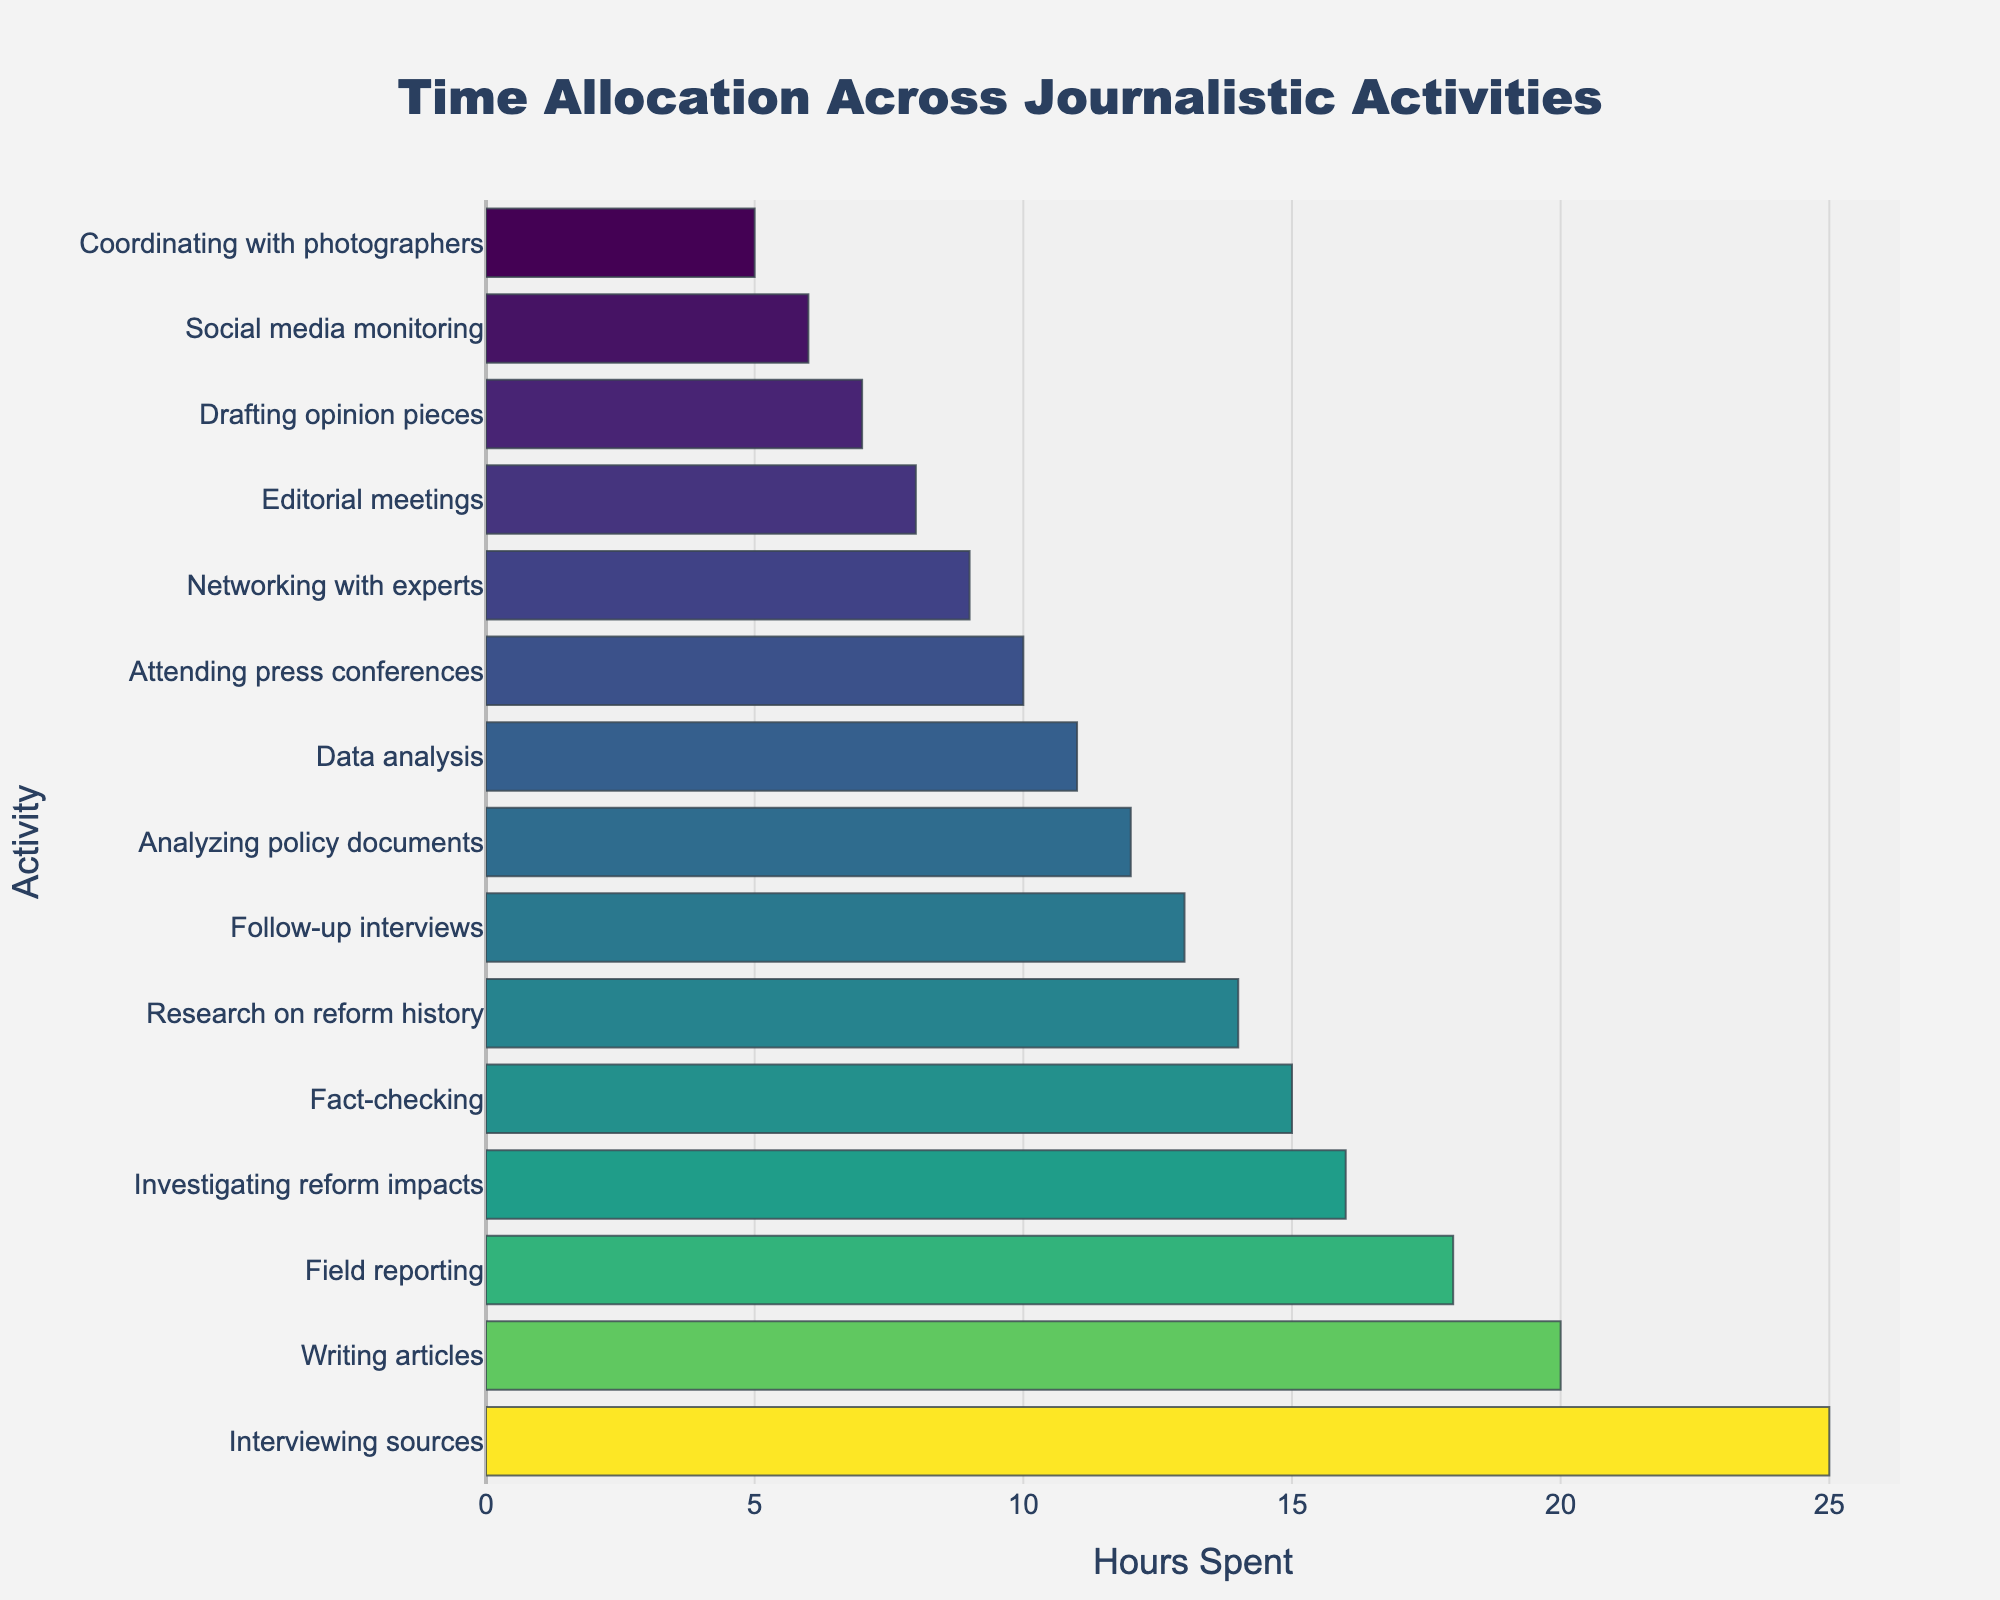What is the title of the plot? The title is located at the top of the figure. It reads 'Time Allocation Across Journalistic Activities.'
Answer: Time Allocation Across Journalistic Activities Which activity takes the most hours? By looking at the horizontal bars, the activity with the longest bar represents the highest number of hours. The longest bar corresponds to 'Interviewing sources.'
Answer: Interviewing sources Which activity takes the least amount of time? The shortest bar on the figure represents the least hours spent on a particular activity. The shortest bar corresponds to 'Coordinating with photographers.'
Answer: Coordinating with photographers How many activities have more than 15 hours allocated to them? Count the number of bars that extend beyond the 15-hour mark on the horizontal axis. There are four such activities: ‘Interviewing sources,’ ‘Writing articles,’ ‘Investigating reform impacts,’ and ‘Field reporting.’
Answer: Four What is the total number of hours spent on 'Research on reform history' and 'Data analysis' combined? Find the hours spent on each activity in the plot and add them together: 'Research on reform history' (14 hours) + 'Data analysis' (11 hours). 14 + 11 = 25
Answer: 25 Compare the time spent on 'Writing articles' and 'Analyzing policy documents.' Which one takes more time and by how much? Look at the length of the bars for both activities. 'Writing articles' takes 20 hours, while 'Analyzing policy documents' takes 12 hours. Subtract 12 from 20 to find the difference. 20 - 12 = 8
Answer: Writing articles, 8 hours What are the ranges of hours spent on different activities? The minimum hours and maximum hours on the x-axis show the range of hours. The hours range from 5 to 25.
Answer: 5 to 25 Which activities have fewer hours than 'Fact-checking'? Identify the hours for 'Fact-checking' (15 hours), then list activities with bars shorter than this value: 'Attending press conferences', 'Analyzing policy documents', 'Editorial meetings', 'Research on reform history', 'Social media monitoring', 'Networking with experts', 'Data analysis', 'Drafting opinion pieces', 'Follow-up interviews', 'Coordinating with photographers'.
Answer: Ten activities If you sum the hours of 'Attending press conferences' and 'Networking with experts,' how does this compare to the hours spent on 'Field reporting'? Find the hours for each activity and sum them: 'Attending press conferences' (10 hours) + 'Networking with experts' (9 hours) = 19 hours. Compare this to 'Field reporting' which takes 18 hours. 19 is 1 more than 18.
Answer: 1 hour more How does the time spent on 'Social media monitoring' compare to 'Drafting opinion pieces'? Check the length of the bars for both activities. 'Social media monitoring' is assigned 6 hours and 'Drafting opinion pieces' is assigned 7 hours. Subtract 6 from 7. 7 - 6 = 1
Answer: Drafting opinion pieces, 1 hour more 